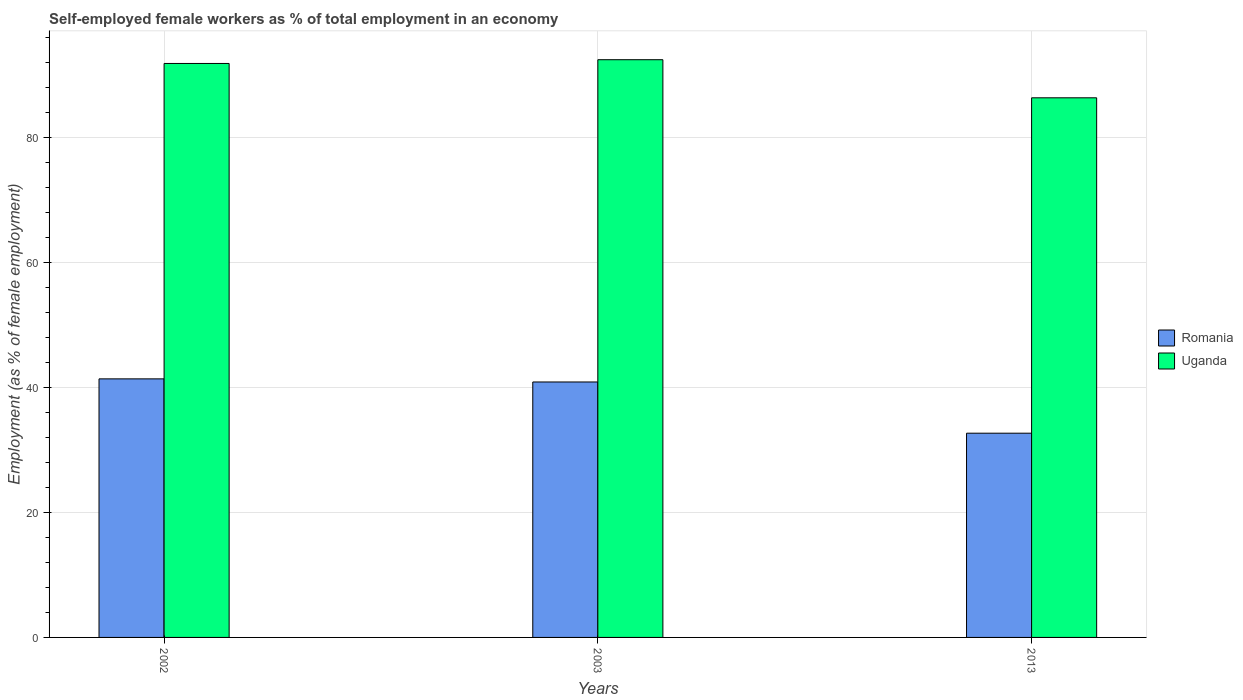How many different coloured bars are there?
Ensure brevity in your answer.  2. How many groups of bars are there?
Your response must be concise. 3. How many bars are there on the 2nd tick from the right?
Provide a short and direct response. 2. What is the percentage of self-employed female workers in Uganda in 2002?
Your answer should be very brief. 91.9. Across all years, what is the maximum percentage of self-employed female workers in Uganda?
Provide a short and direct response. 92.5. Across all years, what is the minimum percentage of self-employed female workers in Uganda?
Offer a very short reply. 86.4. In which year was the percentage of self-employed female workers in Uganda maximum?
Keep it short and to the point. 2003. What is the total percentage of self-employed female workers in Uganda in the graph?
Your response must be concise. 270.8. What is the difference between the percentage of self-employed female workers in Romania in 2003 and that in 2013?
Offer a terse response. 8.2. What is the difference between the percentage of self-employed female workers in Romania in 2003 and the percentage of self-employed female workers in Uganda in 2013?
Your answer should be compact. -45.5. What is the average percentage of self-employed female workers in Uganda per year?
Provide a short and direct response. 90.27. In the year 2002, what is the difference between the percentage of self-employed female workers in Uganda and percentage of self-employed female workers in Romania?
Offer a very short reply. 50.5. What is the ratio of the percentage of self-employed female workers in Uganda in 2002 to that in 2003?
Offer a very short reply. 0.99. What is the difference between the highest and the second highest percentage of self-employed female workers in Uganda?
Give a very brief answer. 0.6. What is the difference between the highest and the lowest percentage of self-employed female workers in Romania?
Keep it short and to the point. 8.7. In how many years, is the percentage of self-employed female workers in Romania greater than the average percentage of self-employed female workers in Romania taken over all years?
Give a very brief answer. 2. What does the 2nd bar from the left in 2003 represents?
Make the answer very short. Uganda. What does the 2nd bar from the right in 2013 represents?
Keep it short and to the point. Romania. How many bars are there?
Provide a succinct answer. 6. What is the difference between two consecutive major ticks on the Y-axis?
Ensure brevity in your answer.  20. How many legend labels are there?
Your response must be concise. 2. How are the legend labels stacked?
Give a very brief answer. Vertical. What is the title of the graph?
Offer a very short reply. Self-employed female workers as % of total employment in an economy. What is the label or title of the X-axis?
Your response must be concise. Years. What is the label or title of the Y-axis?
Your response must be concise. Employment (as % of female employment). What is the Employment (as % of female employment) in Romania in 2002?
Your answer should be very brief. 41.4. What is the Employment (as % of female employment) in Uganda in 2002?
Provide a short and direct response. 91.9. What is the Employment (as % of female employment) in Romania in 2003?
Make the answer very short. 40.9. What is the Employment (as % of female employment) in Uganda in 2003?
Your response must be concise. 92.5. What is the Employment (as % of female employment) in Romania in 2013?
Make the answer very short. 32.7. What is the Employment (as % of female employment) in Uganda in 2013?
Keep it short and to the point. 86.4. Across all years, what is the maximum Employment (as % of female employment) of Romania?
Provide a succinct answer. 41.4. Across all years, what is the maximum Employment (as % of female employment) of Uganda?
Keep it short and to the point. 92.5. Across all years, what is the minimum Employment (as % of female employment) of Romania?
Provide a short and direct response. 32.7. Across all years, what is the minimum Employment (as % of female employment) of Uganda?
Make the answer very short. 86.4. What is the total Employment (as % of female employment) of Romania in the graph?
Your response must be concise. 115. What is the total Employment (as % of female employment) in Uganda in the graph?
Offer a very short reply. 270.8. What is the difference between the Employment (as % of female employment) in Romania in 2002 and that in 2003?
Provide a succinct answer. 0.5. What is the difference between the Employment (as % of female employment) of Uganda in 2002 and that in 2013?
Offer a terse response. 5.5. What is the difference between the Employment (as % of female employment) in Romania in 2003 and that in 2013?
Give a very brief answer. 8.2. What is the difference between the Employment (as % of female employment) of Uganda in 2003 and that in 2013?
Offer a terse response. 6.1. What is the difference between the Employment (as % of female employment) of Romania in 2002 and the Employment (as % of female employment) of Uganda in 2003?
Your answer should be compact. -51.1. What is the difference between the Employment (as % of female employment) in Romania in 2002 and the Employment (as % of female employment) in Uganda in 2013?
Provide a succinct answer. -45. What is the difference between the Employment (as % of female employment) in Romania in 2003 and the Employment (as % of female employment) in Uganda in 2013?
Your answer should be very brief. -45.5. What is the average Employment (as % of female employment) in Romania per year?
Ensure brevity in your answer.  38.33. What is the average Employment (as % of female employment) in Uganda per year?
Keep it short and to the point. 90.27. In the year 2002, what is the difference between the Employment (as % of female employment) in Romania and Employment (as % of female employment) in Uganda?
Offer a very short reply. -50.5. In the year 2003, what is the difference between the Employment (as % of female employment) of Romania and Employment (as % of female employment) of Uganda?
Your answer should be compact. -51.6. In the year 2013, what is the difference between the Employment (as % of female employment) of Romania and Employment (as % of female employment) of Uganda?
Keep it short and to the point. -53.7. What is the ratio of the Employment (as % of female employment) in Romania in 2002 to that in 2003?
Your response must be concise. 1.01. What is the ratio of the Employment (as % of female employment) in Uganda in 2002 to that in 2003?
Keep it short and to the point. 0.99. What is the ratio of the Employment (as % of female employment) of Romania in 2002 to that in 2013?
Offer a very short reply. 1.27. What is the ratio of the Employment (as % of female employment) in Uganda in 2002 to that in 2013?
Give a very brief answer. 1.06. What is the ratio of the Employment (as % of female employment) in Romania in 2003 to that in 2013?
Offer a terse response. 1.25. What is the ratio of the Employment (as % of female employment) in Uganda in 2003 to that in 2013?
Keep it short and to the point. 1.07. What is the difference between the highest and the second highest Employment (as % of female employment) in Uganda?
Keep it short and to the point. 0.6. What is the difference between the highest and the lowest Employment (as % of female employment) of Uganda?
Ensure brevity in your answer.  6.1. 